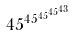<formula> <loc_0><loc_0><loc_500><loc_500>4 5 ^ { 4 5 ^ { 4 5 ^ { 4 5 ^ { 4 3 } } } }</formula> 